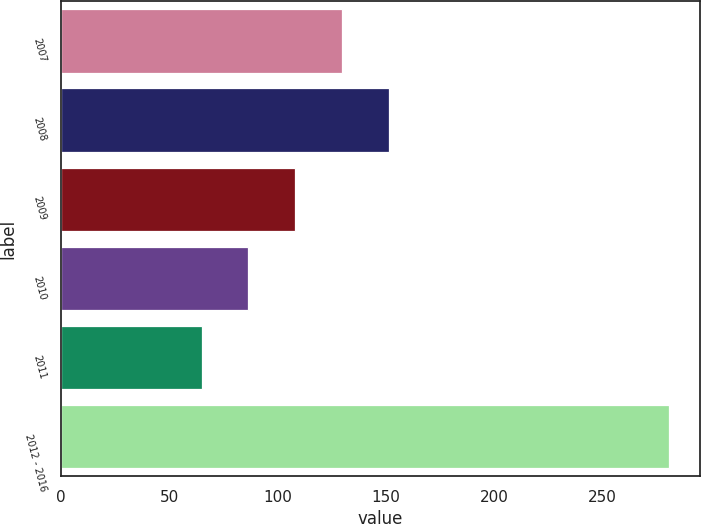Convert chart to OTSL. <chart><loc_0><loc_0><loc_500><loc_500><bar_chart><fcel>2007<fcel>2008<fcel>2009<fcel>2010<fcel>2011<fcel>2012 - 2016<nl><fcel>129.8<fcel>151.4<fcel>108.2<fcel>86.6<fcel>65<fcel>281<nl></chart> 